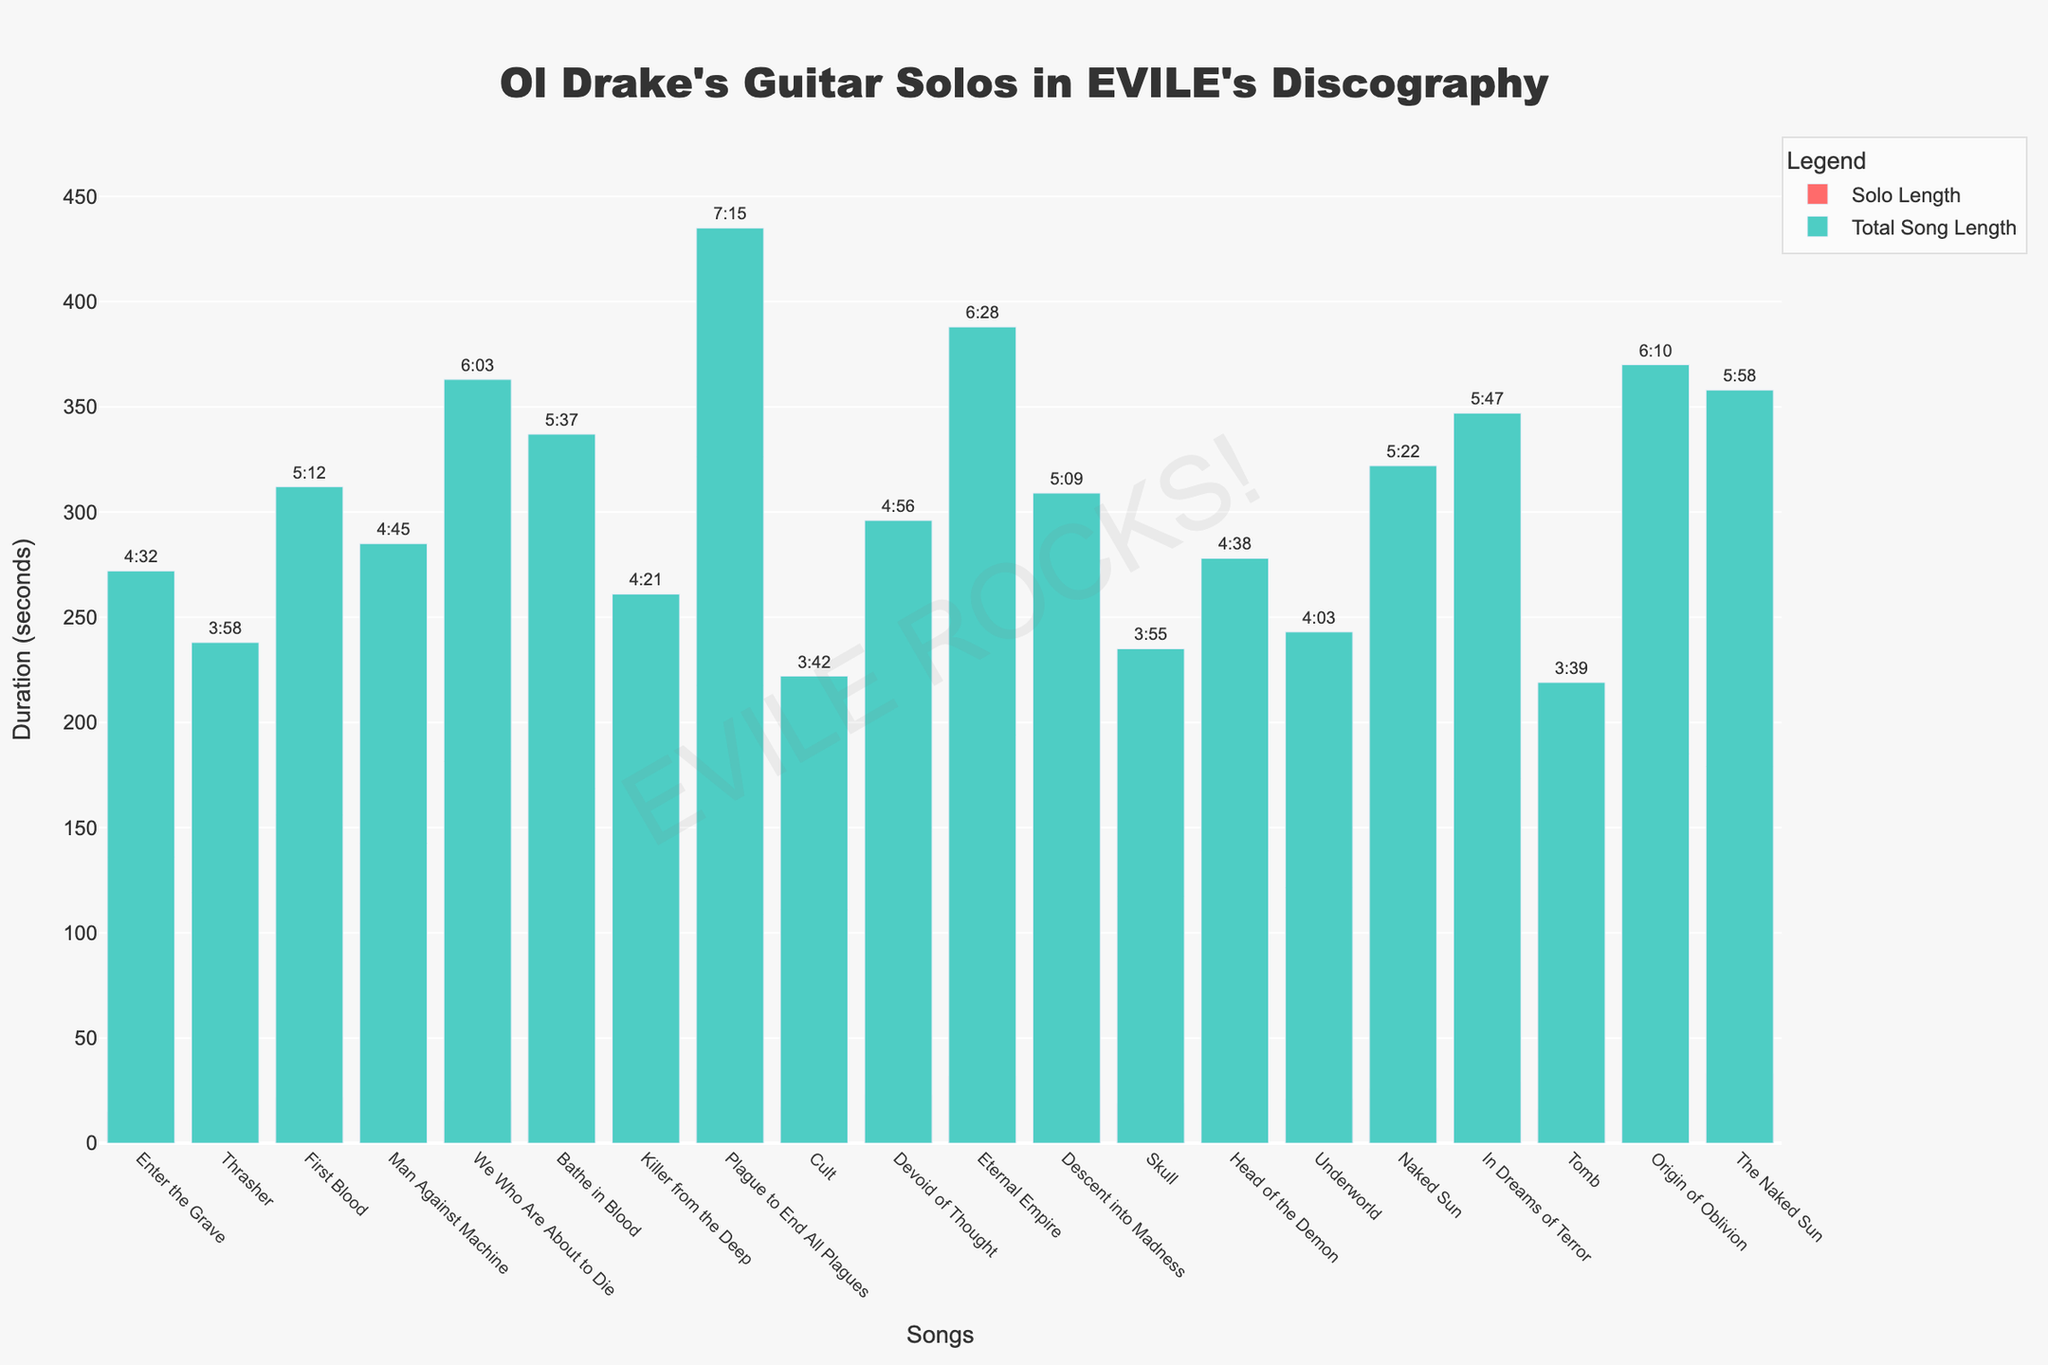What is the shortest solo length in the chart? To find the shortest solo length, scan the "Solo Length (seconds)" column for the smallest value among all the bars. The shortest solo length is 15 seconds for the song "Enter the Grave."
Answer: 15 seconds Which song has the longest total song length? To determine the song with the longest total length, compare the "Total Song Length (seconds)" values across all bars. The longest total song length is 435 seconds for "Plague to End All Plagues."
Answer: Plague to End All Plagues What is the average guitar solo length in the chart? To calculate the average solo length, sum all the solo lengths and divide by the number of songs: (15 + 18 + 22 + 25 + 20 + 30 + 28 + 35 + 17 + 23 + 32 + 27 + 19 + 24 + 21 + 26 + 29 + 16 + 31 + 33) / 20 = 530 / 20. The average solo length is 26.5 seconds.
Answer: 26.5 seconds Which two songs have the most similar total lengths? To find the songs with the most similar total lengths, subtract the total lengths of each pair of songs. The two with the smallest difference are "Descent into Madness" (309 seconds) and "Man Against Machine" (285 seconds), with a difference of 24 seconds.
Answer: Descent into Madness and Man Against Machine What is the difference between the longest and shortest guitar solo lengths? The longest guitar solo is 35 seconds for "Plague to End All Plagues," and the shortest is 15 seconds for "Enter the Grave." The difference is 35 - 15 = 20 seconds.
Answer: 20 seconds Which song has the shortest total length, and how long is it? To find the shortest total song length, compare the "Total Song Length (seconds)" values for all songs. "Tomb" has the shortest total song length of 219 seconds.
Answer: Tomb, 219 seconds What is the total combined length of all solos? Sum the lengths of all solos: 15 + 18 + 22 + 25 + 20 + 30 + 28 + 35 + 17 + 23 + 32 + 27 + 19 + 24 + 21 + 26 + 29 + 16 + 31 + 33 = 530 seconds.
Answer: 530 seconds 